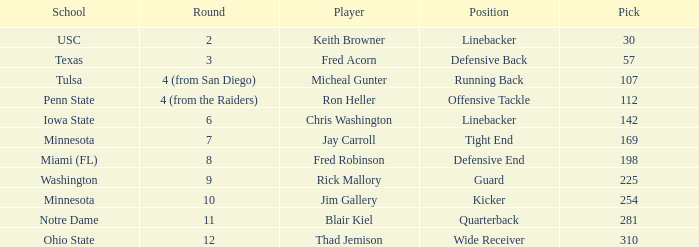What is Thad Jemison's position? Wide Receiver. 